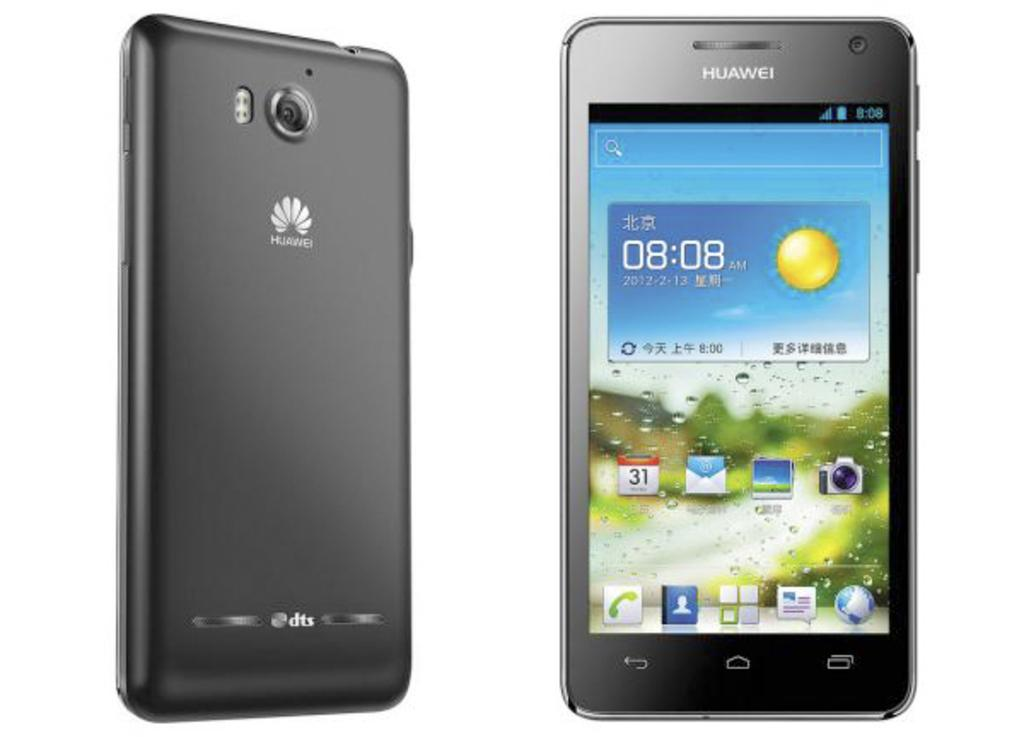<image>
Render a clear and concise summary of the photo. A front and a back shot of a phone, the front shot reads 08.08. 